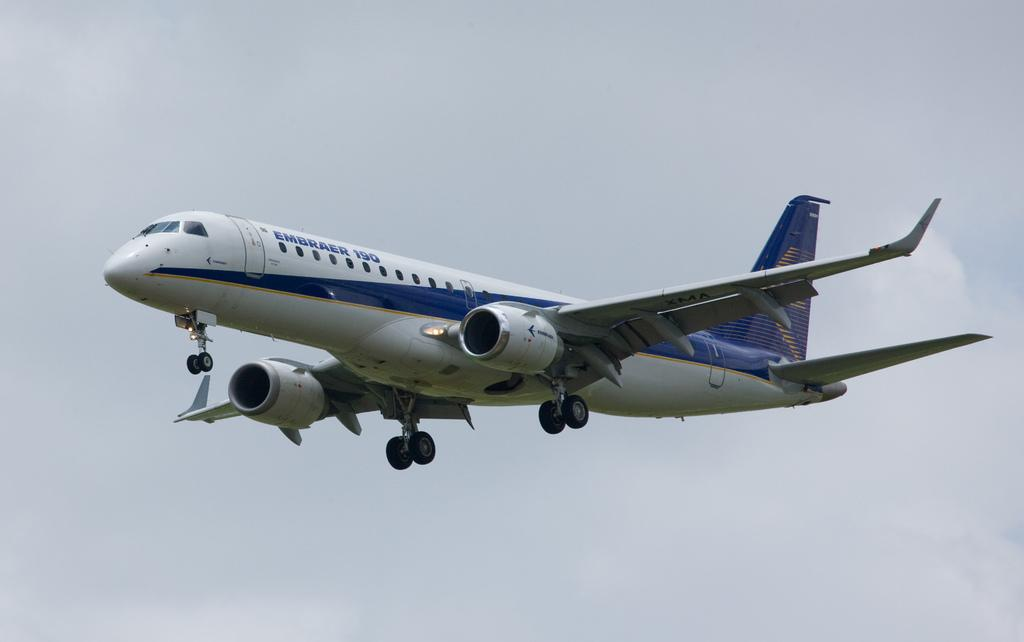What is the main subject of the image? The main subject of the image is an airplane. What is the airplane doing in the image? The airplane is flying in the air. What colors can be seen on the airplane? The airplane is white and blue in color. What can be seen in the background of the image? There is a sky visible in the background of the image. What type of apparel is the train wearing in the image? There is no train present in the image, so it cannot be wearing any apparel. 